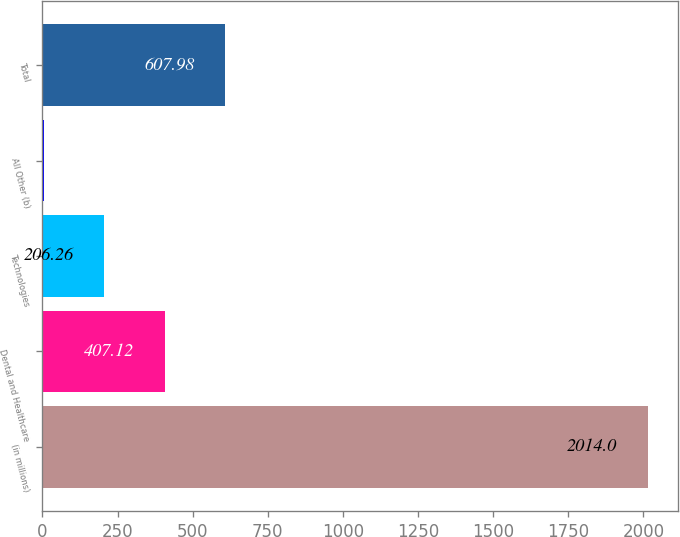<chart> <loc_0><loc_0><loc_500><loc_500><bar_chart><fcel>(in millions)<fcel>Dental and Healthcare<fcel>Technologies<fcel>All Other (b)<fcel>Total<nl><fcel>2014<fcel>407.12<fcel>206.26<fcel>5.4<fcel>607.98<nl></chart> 